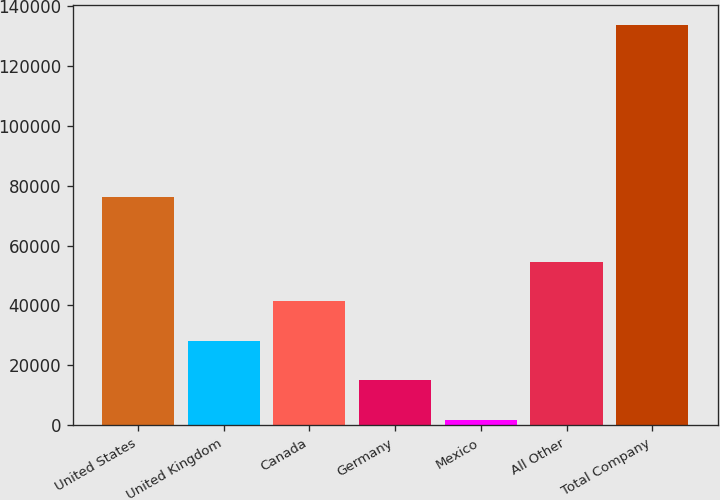<chart> <loc_0><loc_0><loc_500><loc_500><bar_chart><fcel>United States<fcel>United Kingdom<fcel>Canada<fcel>Germany<fcel>Mexico<fcel>All Other<fcel>Total Company<nl><fcel>76055<fcel>28166.2<fcel>41340.3<fcel>14992.1<fcel>1818<fcel>54514.4<fcel>133559<nl></chart> 